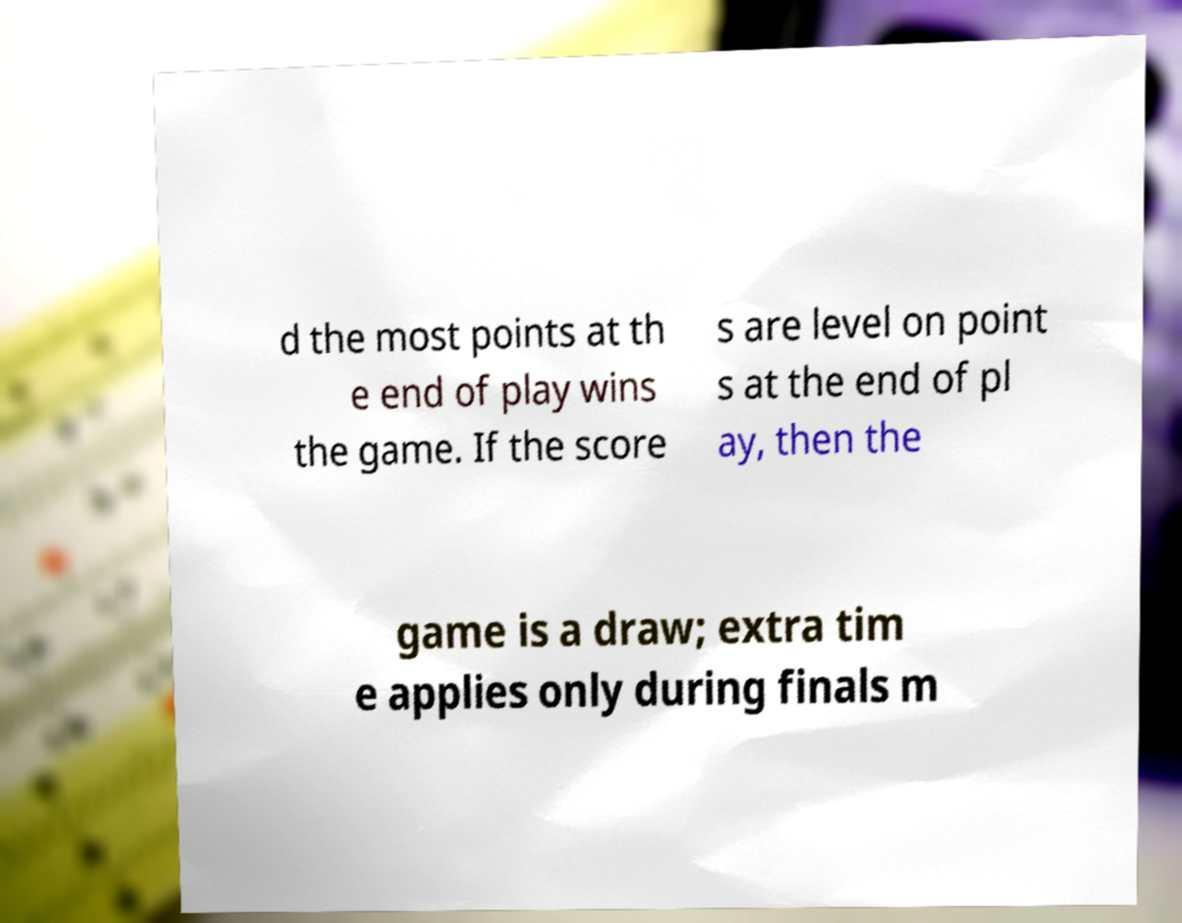Please identify and transcribe the text found in this image. d the most points at th e end of play wins the game. If the score s are level on point s at the end of pl ay, then the game is a draw; extra tim e applies only during finals m 